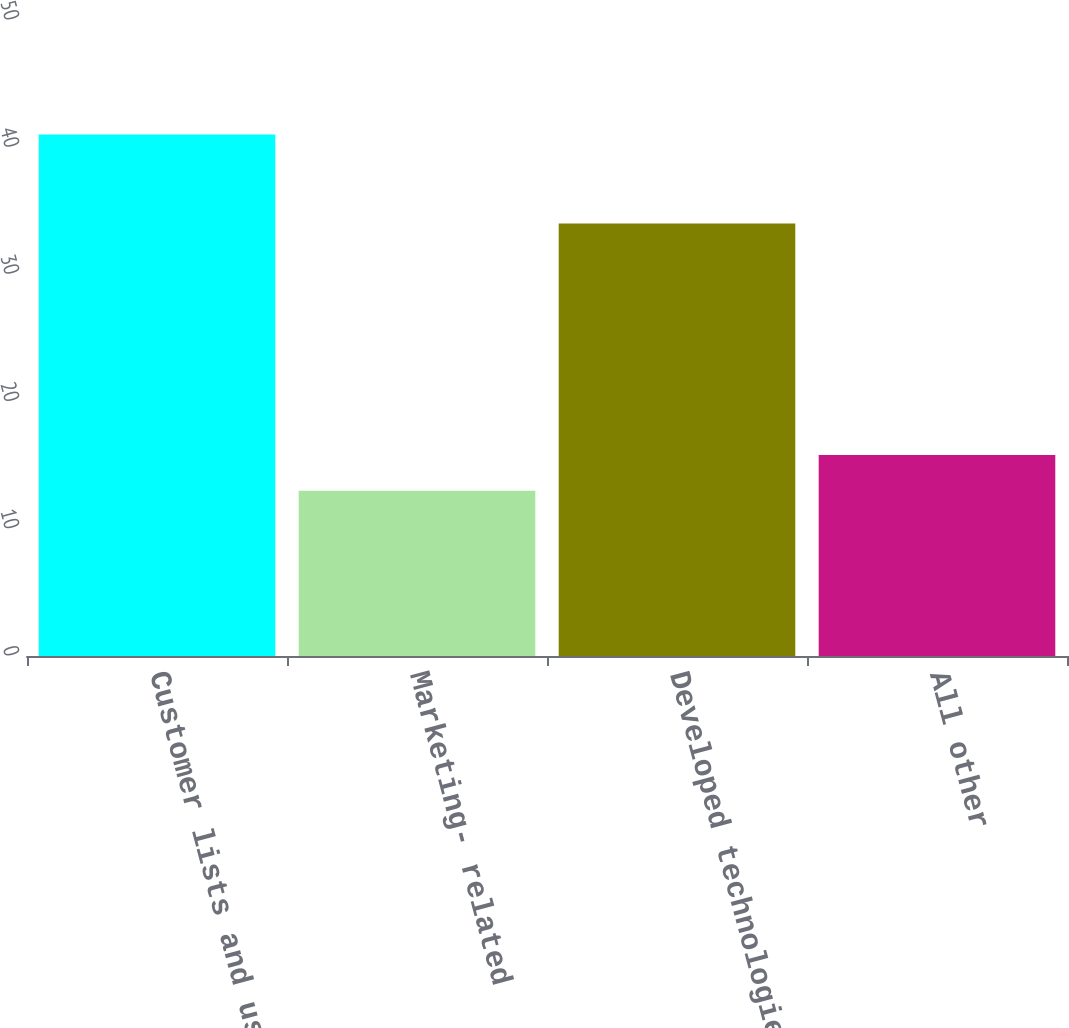Convert chart to OTSL. <chart><loc_0><loc_0><loc_500><loc_500><bar_chart><fcel>Customer lists and user base<fcel>Marketing- related<fcel>Developed technologies<fcel>All other<nl><fcel>41<fcel>13<fcel>34<fcel>15.8<nl></chart> 